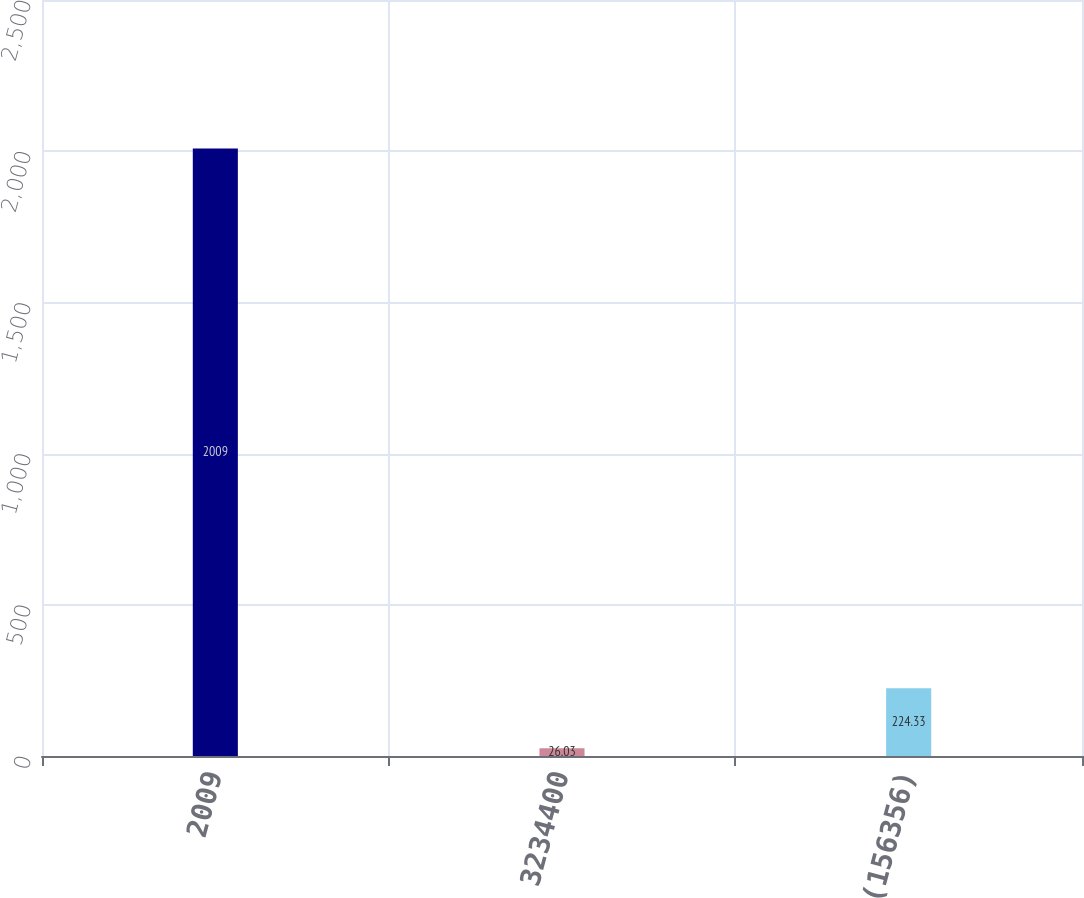Convert chart to OTSL. <chart><loc_0><loc_0><loc_500><loc_500><bar_chart><fcel>2009<fcel>3234400<fcel>(156356)<nl><fcel>2009<fcel>26.03<fcel>224.33<nl></chart> 